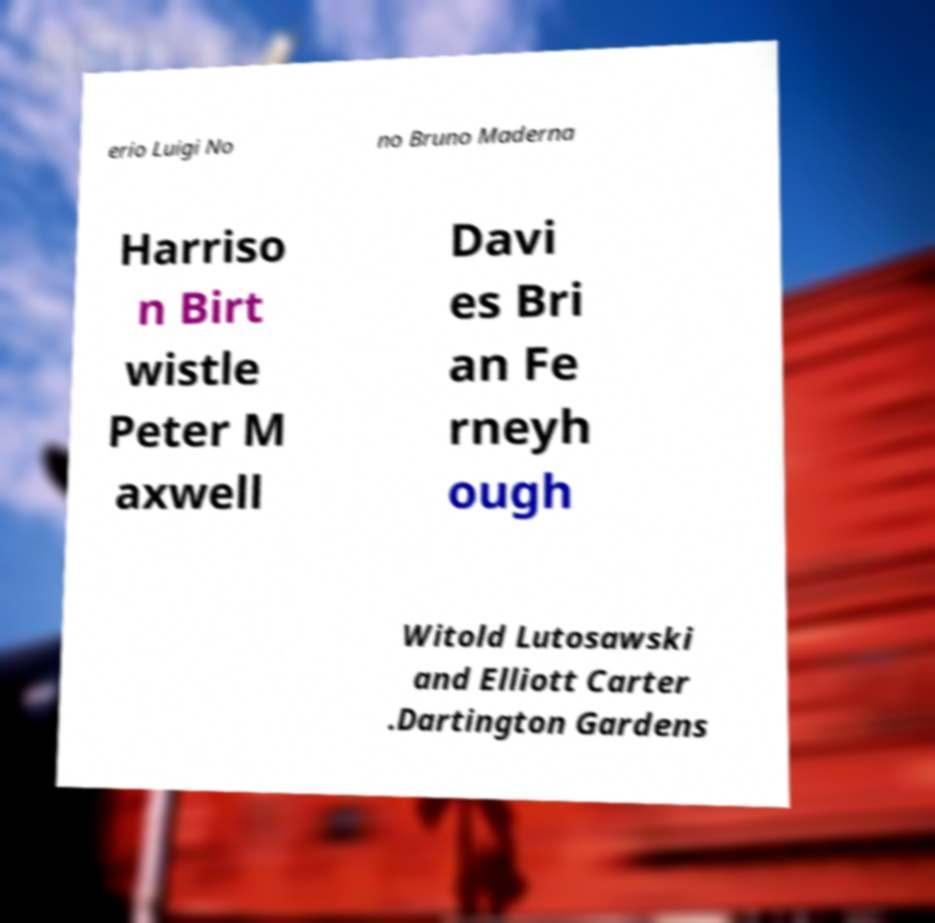What messages or text are displayed in this image? I need them in a readable, typed format. erio Luigi No no Bruno Maderna Harriso n Birt wistle Peter M axwell Davi es Bri an Fe rneyh ough Witold Lutosawski and Elliott Carter .Dartington Gardens 